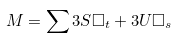Convert formula to latex. <formula><loc_0><loc_0><loc_500><loc_500>M = \sum 3 S \Box _ { t } + 3 U \Box _ { s }</formula> 